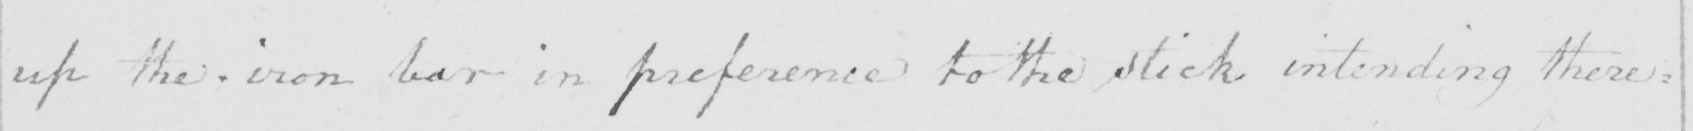Transcribe the text shown in this historical manuscript line. up the iron bar in preference to the stick intending there= 